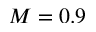<formula> <loc_0><loc_0><loc_500><loc_500>M = 0 . 9</formula> 